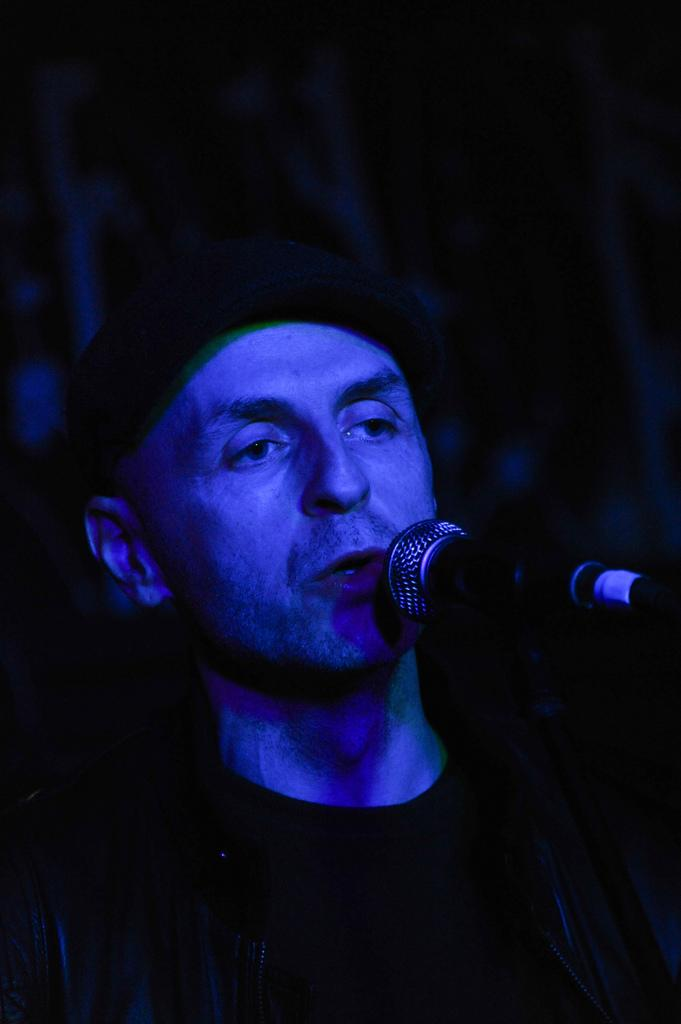Who or what is the main subject of the image? There is a person in the image. What object is visible in the image that is typically used for amplifying sound? There is a microphone in the image. Can you describe the background of the image? The background of the image is dark. What type of interest can be seen growing on the person's head in the image? There is no interest growing on the person's head in the image. What kind of apparatus is being used to help the person in the image? There is no apparatus being used to help the person in the image; only a microphone is visible. 